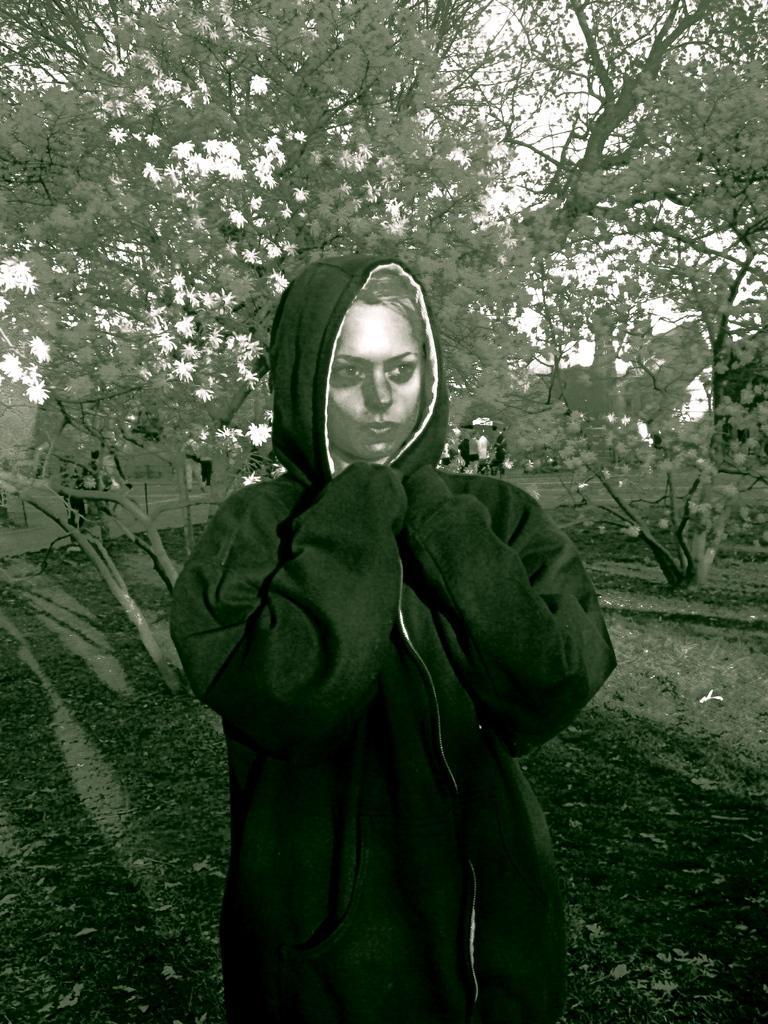Can you describe this image briefly? Here in this picture we can see a woman standing on the ground and we can see she is wearing jacket and behind her we can see the ground is fully covered with grass and we can also see plants and trees present and we can see some flowers present on the trees. 